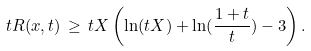Convert formula to latex. <formula><loc_0><loc_0><loc_500><loc_500>t R ( x , t ) \, \geq \, t X \left ( \ln ( t X ) + \ln ( \frac { 1 + t } { t } ) - 3 \right ) .</formula> 